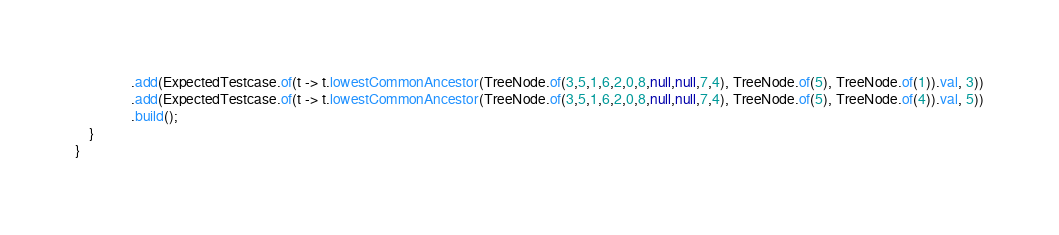<code> <loc_0><loc_0><loc_500><loc_500><_Java_>                .add(ExpectedTestcase.of(t -> t.lowestCommonAncestor(TreeNode.of(3,5,1,6,2,0,8,null,null,7,4), TreeNode.of(5), TreeNode.of(1)).val, 3))
                .add(ExpectedTestcase.of(t -> t.lowestCommonAncestor(TreeNode.of(3,5,1,6,2,0,8,null,null,7,4), TreeNode.of(5), TreeNode.of(4)).val, 5))
                .build();
    }
}</code> 